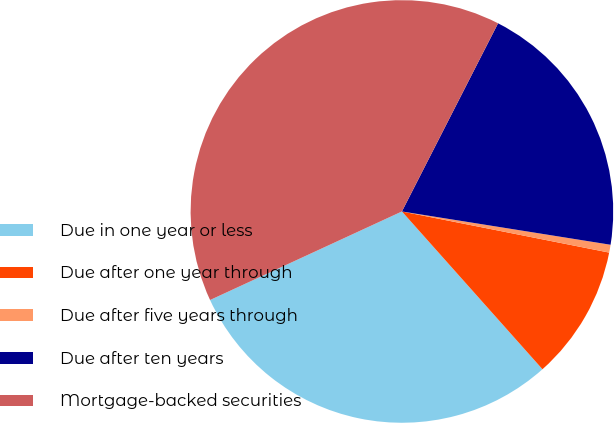Convert chart. <chart><loc_0><loc_0><loc_500><loc_500><pie_chart><fcel>Due in one year or less<fcel>Due after one year through<fcel>Due after five years through<fcel>Due after ten years<fcel>Mortgage-backed securities<nl><fcel>29.7%<fcel>10.3%<fcel>0.6%<fcel>20.0%<fcel>39.4%<nl></chart> 